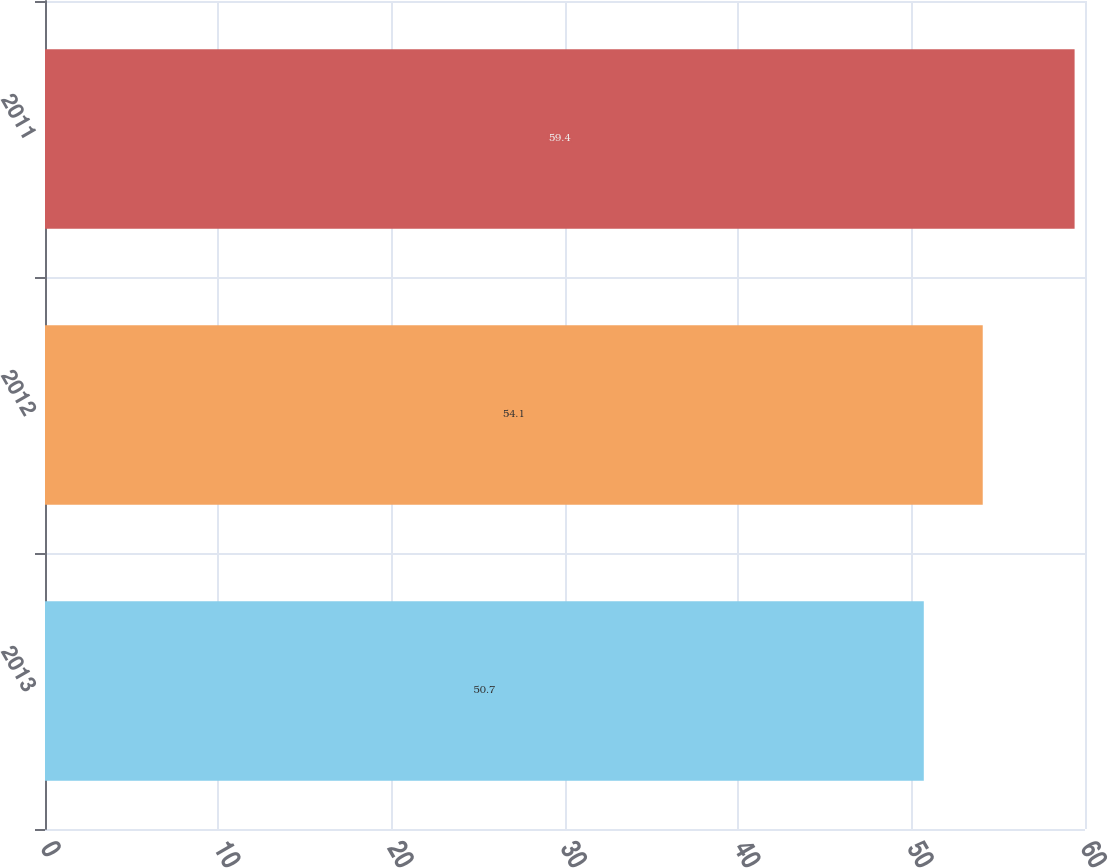Convert chart to OTSL. <chart><loc_0><loc_0><loc_500><loc_500><bar_chart><fcel>2013<fcel>2012<fcel>2011<nl><fcel>50.7<fcel>54.1<fcel>59.4<nl></chart> 